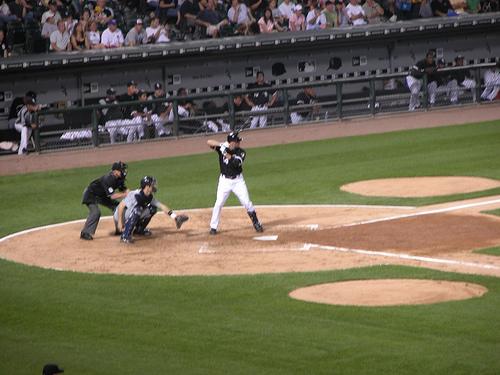If the man hits the ball will he try to go touch first base?
Short answer required. Yes. Is this event sponsored by Bank of America?
Answer briefly. No. What is between the baseball players and the camera?
Quick response, please. Grass. What is on the catchers hand?
Keep it brief. Glove. What is the standing player wearing on his lower left leg?
Quick response, please. Brace. What game are these men playing?
Keep it brief. Baseball. 